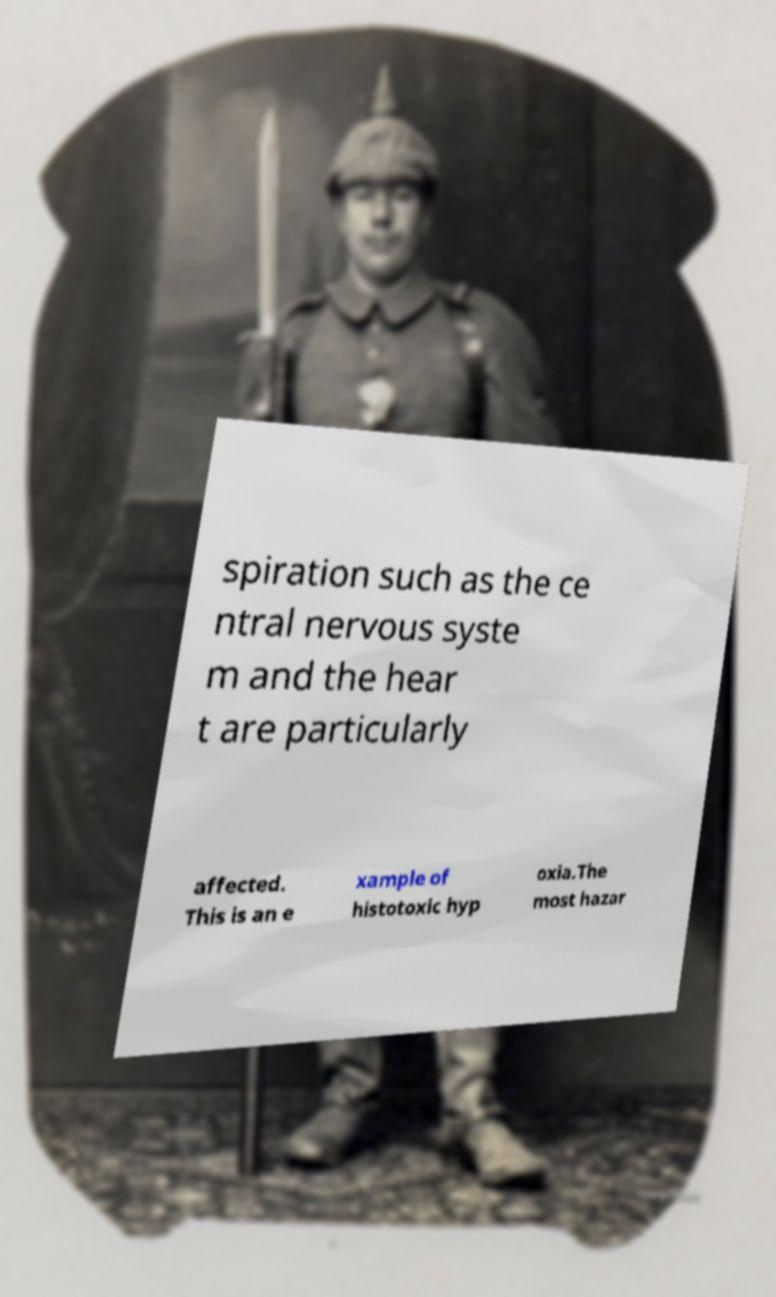Can you accurately transcribe the text from the provided image for me? spiration such as the ce ntral nervous syste m and the hear t are particularly affected. This is an e xample of histotoxic hyp oxia.The most hazar 